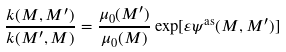<formula> <loc_0><loc_0><loc_500><loc_500>\frac { k ( M , M ^ { \prime } ) } { k ( M ^ { \prime } , M ) } = \frac { \mu _ { 0 } ( M ^ { \prime } ) } { \mu _ { 0 } ( M ) } \exp [ \varepsilon \psi ^ { \text {as} } ( M , M ^ { \prime } ) ]</formula> 